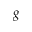Convert formula to latex. <formula><loc_0><loc_0><loc_500><loc_500>g</formula> 